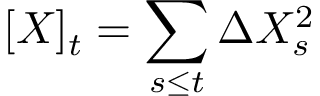<formula> <loc_0><loc_0><loc_500><loc_500>[ X ] _ { t } = \sum _ { s \leq t } \Delta X _ { s } ^ { 2 }</formula> 